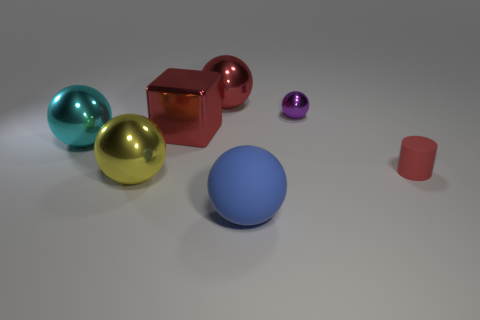Are there any other things that are the same material as the large yellow thing?
Offer a very short reply. Yes. There is a small purple thing that is the same shape as the big yellow object; what is it made of?
Provide a short and direct response. Metal. Are there fewer large cyan spheres that are in front of the big cyan shiny object than big cyan things?
Offer a terse response. Yes. There is a red metal thing behind the small metallic object; is it the same shape as the yellow metallic object?
Ensure brevity in your answer.  Yes. Are there any other things that have the same color as the small shiny thing?
Provide a short and direct response. No. There is a object that is the same material as the tiny red cylinder; what size is it?
Offer a terse response. Large. What material is the big sphere that is on the right side of the red metal thing behind the ball to the right of the big blue matte object?
Your response must be concise. Rubber. Are there fewer large red spheres than blue shiny objects?
Make the answer very short. No. Is the large cyan object made of the same material as the purple object?
Give a very brief answer. Yes. What shape is the large metal thing that is the same color as the big cube?
Offer a very short reply. Sphere. 